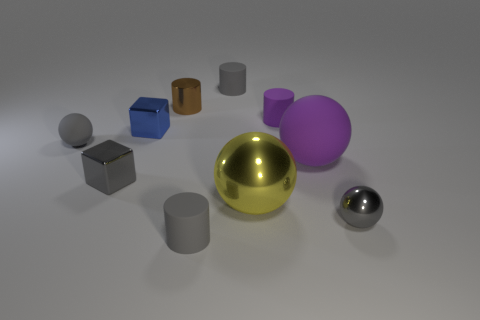There is another sphere that is the same color as the tiny matte sphere; what size is it?
Your response must be concise. Small. How many large shiny things are the same color as the small metal cylinder?
Your answer should be compact. 0. What is the shape of the blue metallic thing?
Make the answer very short. Cube. What color is the ball that is to the right of the tiny gray rubber ball and left of the big purple thing?
Give a very brief answer. Yellow. What is the material of the gray block?
Provide a short and direct response. Metal. There is a metallic thing behind the blue shiny cube; what is its shape?
Ensure brevity in your answer.  Cylinder. What is the color of the metallic cylinder that is the same size as the blue object?
Ensure brevity in your answer.  Brown. Does the tiny gray object in front of the gray metallic sphere have the same material as the blue block?
Ensure brevity in your answer.  No. What is the size of the shiny thing that is both behind the purple ball and on the left side of the brown shiny cylinder?
Your response must be concise. Small. What is the size of the gray sphere that is behind the large yellow thing?
Offer a terse response. Small. 